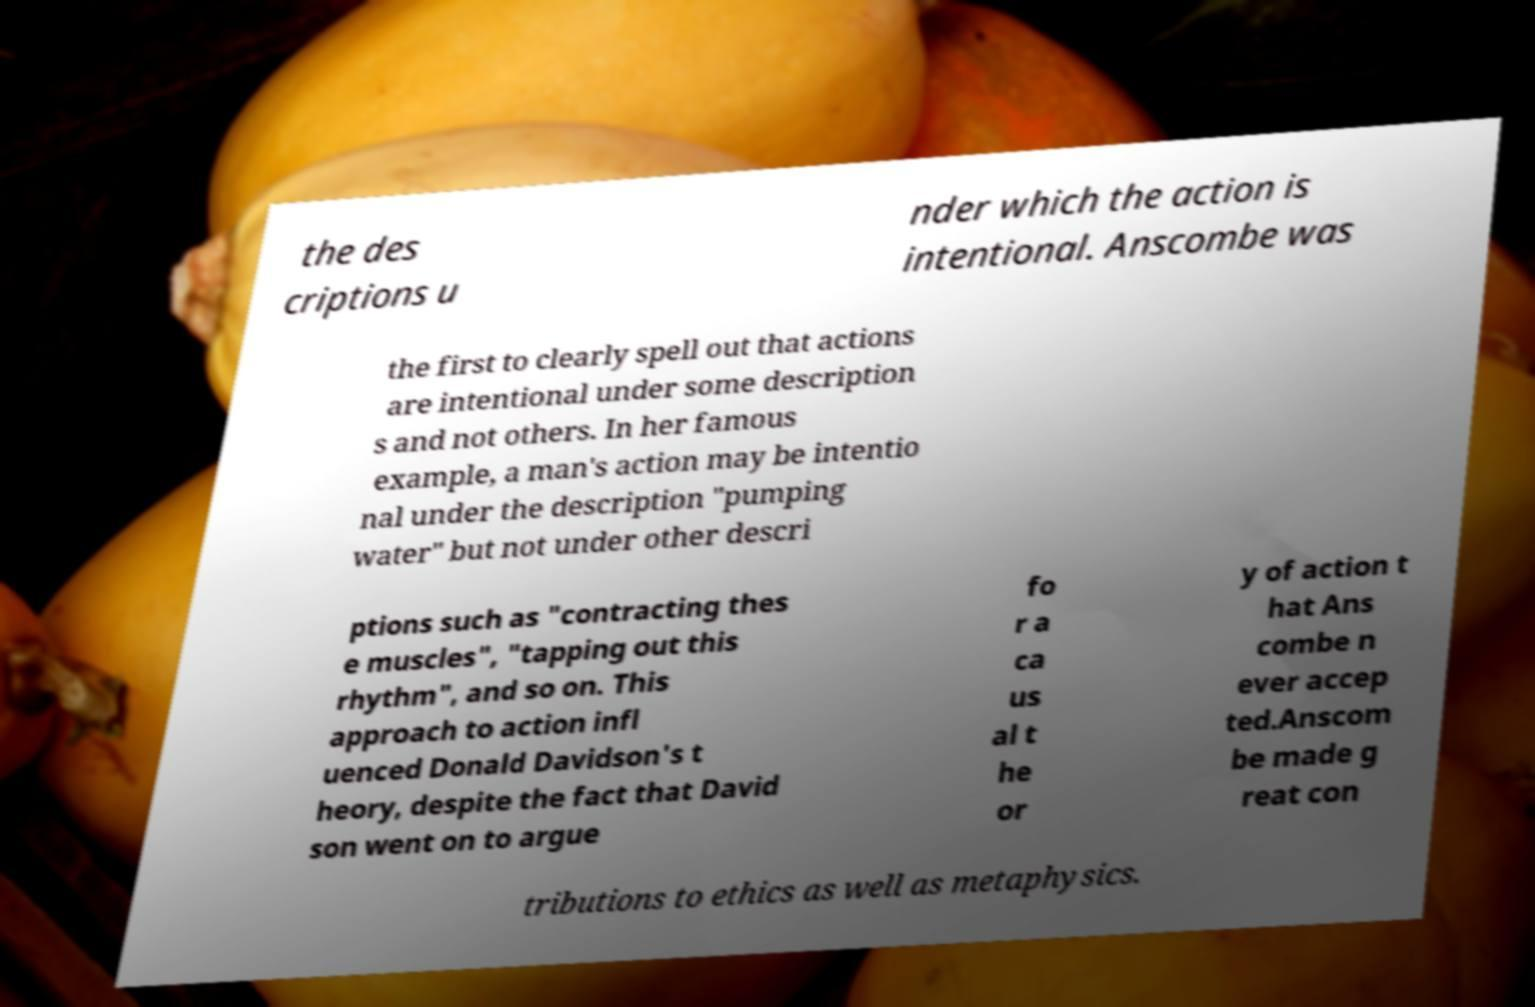Can you read and provide the text displayed in the image?This photo seems to have some interesting text. Can you extract and type it out for me? the des criptions u nder which the action is intentional. Anscombe was the first to clearly spell out that actions are intentional under some description s and not others. In her famous example, a man's action may be intentio nal under the description "pumping water" but not under other descri ptions such as "contracting thes e muscles", "tapping out this rhythm", and so on. This approach to action infl uenced Donald Davidson's t heory, despite the fact that David son went on to argue fo r a ca us al t he or y of action t hat Ans combe n ever accep ted.Anscom be made g reat con tributions to ethics as well as metaphysics. 